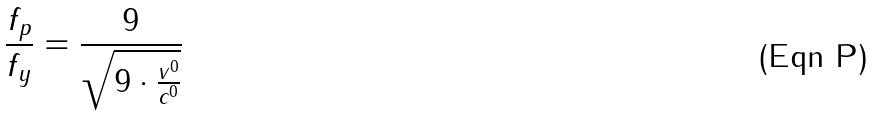Convert formula to latex. <formula><loc_0><loc_0><loc_500><loc_500>\frac { f _ { p } } { f _ { y } } = \frac { 9 } { \sqrt { 9 \cdot \frac { v ^ { 0 } } { c ^ { 0 } } } }</formula> 